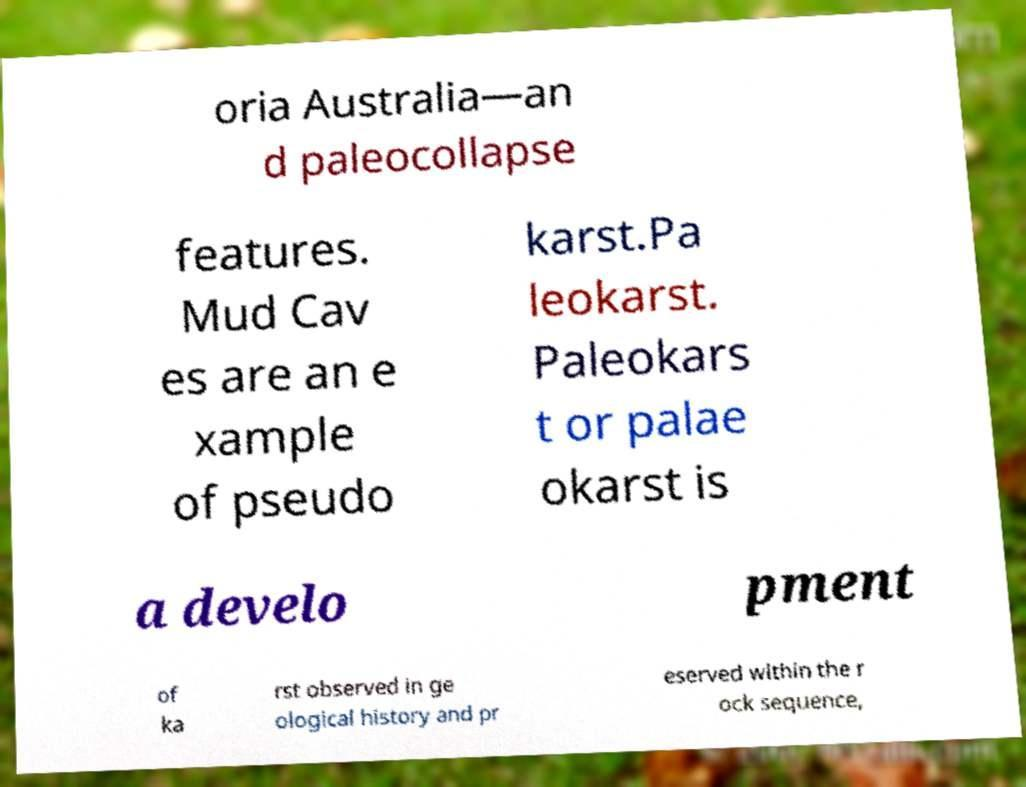Could you assist in decoding the text presented in this image and type it out clearly? oria Australia—an d paleocollapse features. Mud Cav es are an e xample of pseudo karst.Pa leokarst. Paleokars t or palae okarst is a develo pment of ka rst observed in ge ological history and pr eserved within the r ock sequence, 